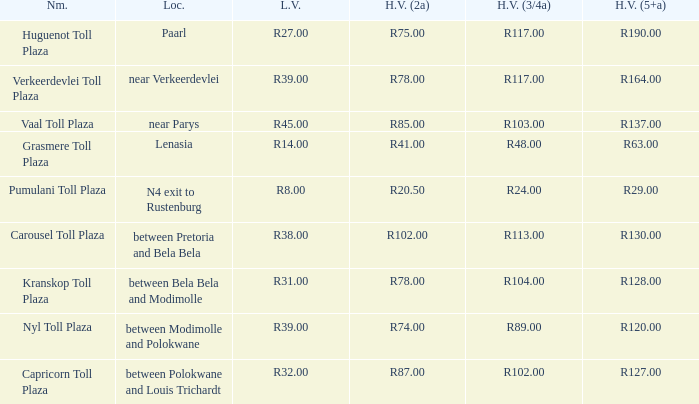00? R32.00. 